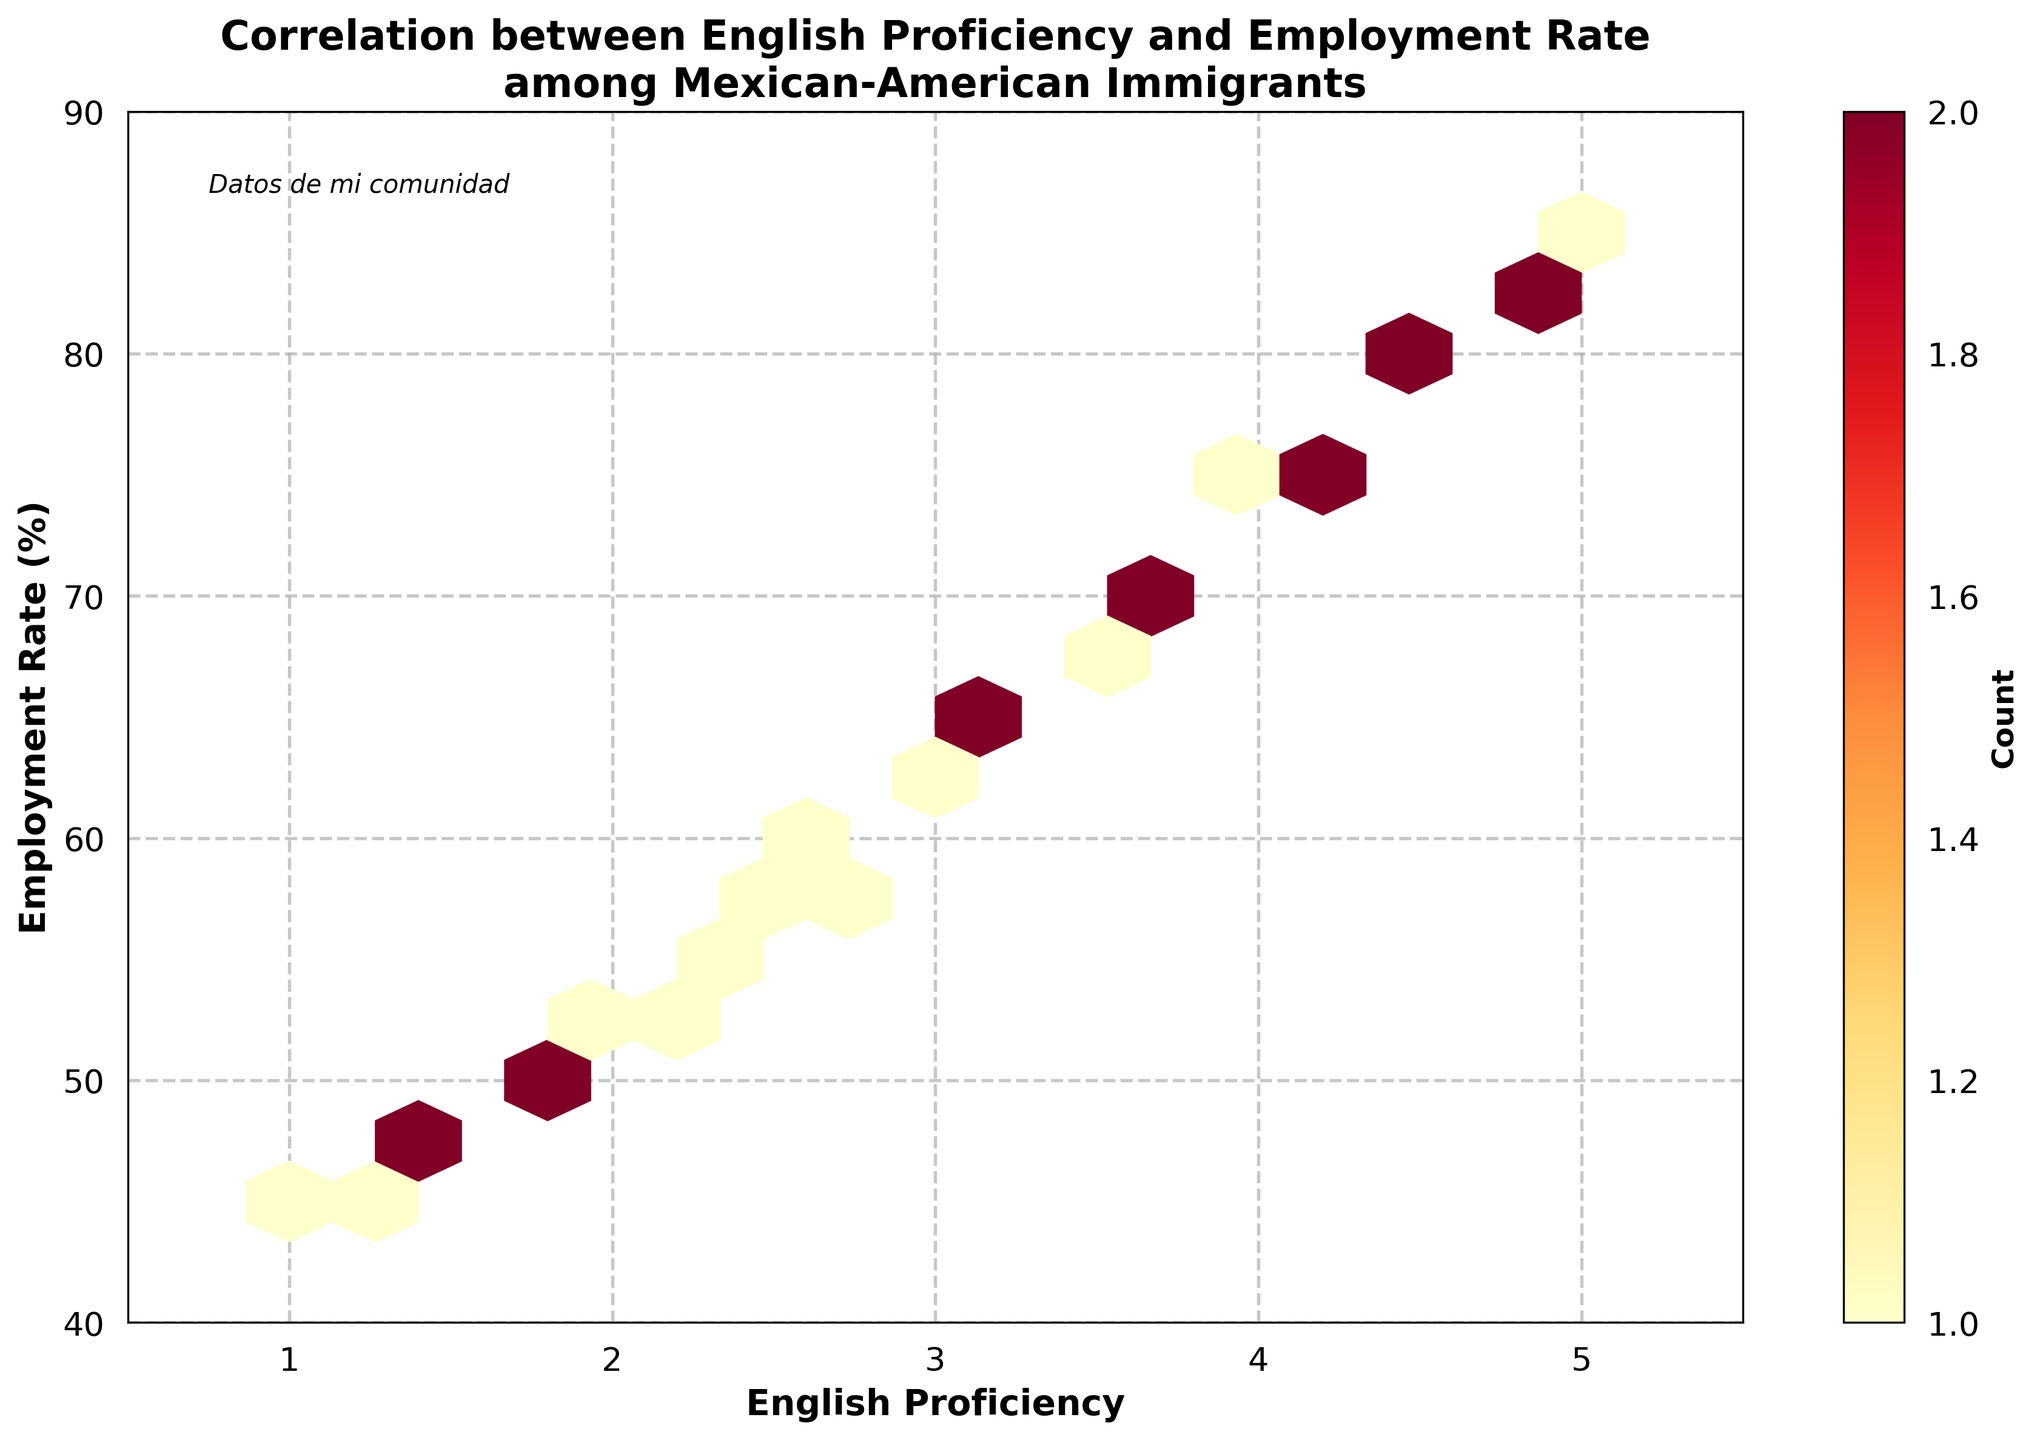What is the title of the figure? The title of the figure is prominently displayed at the top. It reads, "Correlation between English Proficiency and Employment Rate among Mexican-American Immigrants".
Answer: Correlation between English Proficiency and Employment Rate among Mexican-American Immigrants What are the ranges of the x-axis and y-axis? The x-axis ranges from 0.5 to 5.5, representing English Proficiency levels, and the y-axis ranges from 40 to 90, representing Employment Rates in percentage.
Answer: x: 0.5 to 5.5, y: 40 to 90 What does the color of the hex cells represent? The color of the hex cells represents the count of data points within each hexagonal bin, with darker colors indicating higher counts. This can be inferred from the color bar on the right.
Answer: Count of data points Which English proficiency level has the highest employment rate? By observing the densest and highest hexbin, the English proficiency level around 5 has the highest employment rate, indicated at 85%.
Answer: 5 How are the English proficiency levels and employment rates correlated? The figure shows a positive correlation as higher English proficiency levels generally correspond to higher employment rates. This is visually indicated by the upward trend in data density.
Answer: Positively correlated What is the hexbin grid size, and how many hex cells are there in this plot? The hexbin grid size is 15, which defines how many hexagonal cells span the width of the plot. Visually estimating, the plot consists of a uniform grid pattern, suggesting there are roughly 15 x 10 = 150 hex cells.
Answer: 150 hex cells What is indicated by the text "Datos de mi comunidad"? The text "Datos de mi comunidad" at the top left of the figure implies these data points relate specifically to the speaker’s community, adding a personal context to the analysis.
Answer: Community-specific data Between which English proficiency levels do you observe the highest density of data points? The highest density of data points is observed around an English proficiency level of approximately 4 and 4.5, as indicated by the darkest hex cells in this region.
Answer: Around 4 and 4.5 Comparing English proficiency levels of 1 and 5, how much does the employment rate increase? The employment rate increases from approximately 45% at an English proficiency level of 1 to approximately 85% at level 5. The increase is calculated as 85% - 45% = 40%.
Answer: 40% How does the plot visually indicate the grid pattern? The plot visually indicates the hexbin grid pattern by arranging hexagonal cells in a honeycomb structure, where each hexagon represents the count of data points falling within that bin. Light hex cells have fewer data points, while darker cells have more.
Answer: Hexagonal honeycomb structure 